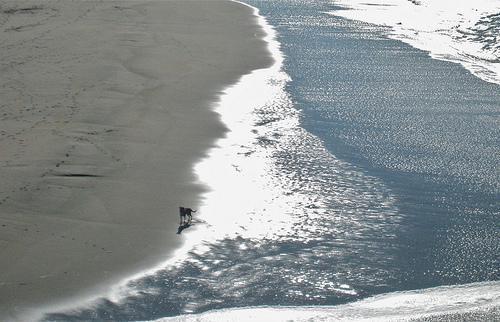How many animals are there?
Give a very brief answer. 1. How many bodies of water are in the picture?
Give a very brief answer. 1. How many dogs are shown?
Give a very brief answer. 1. 